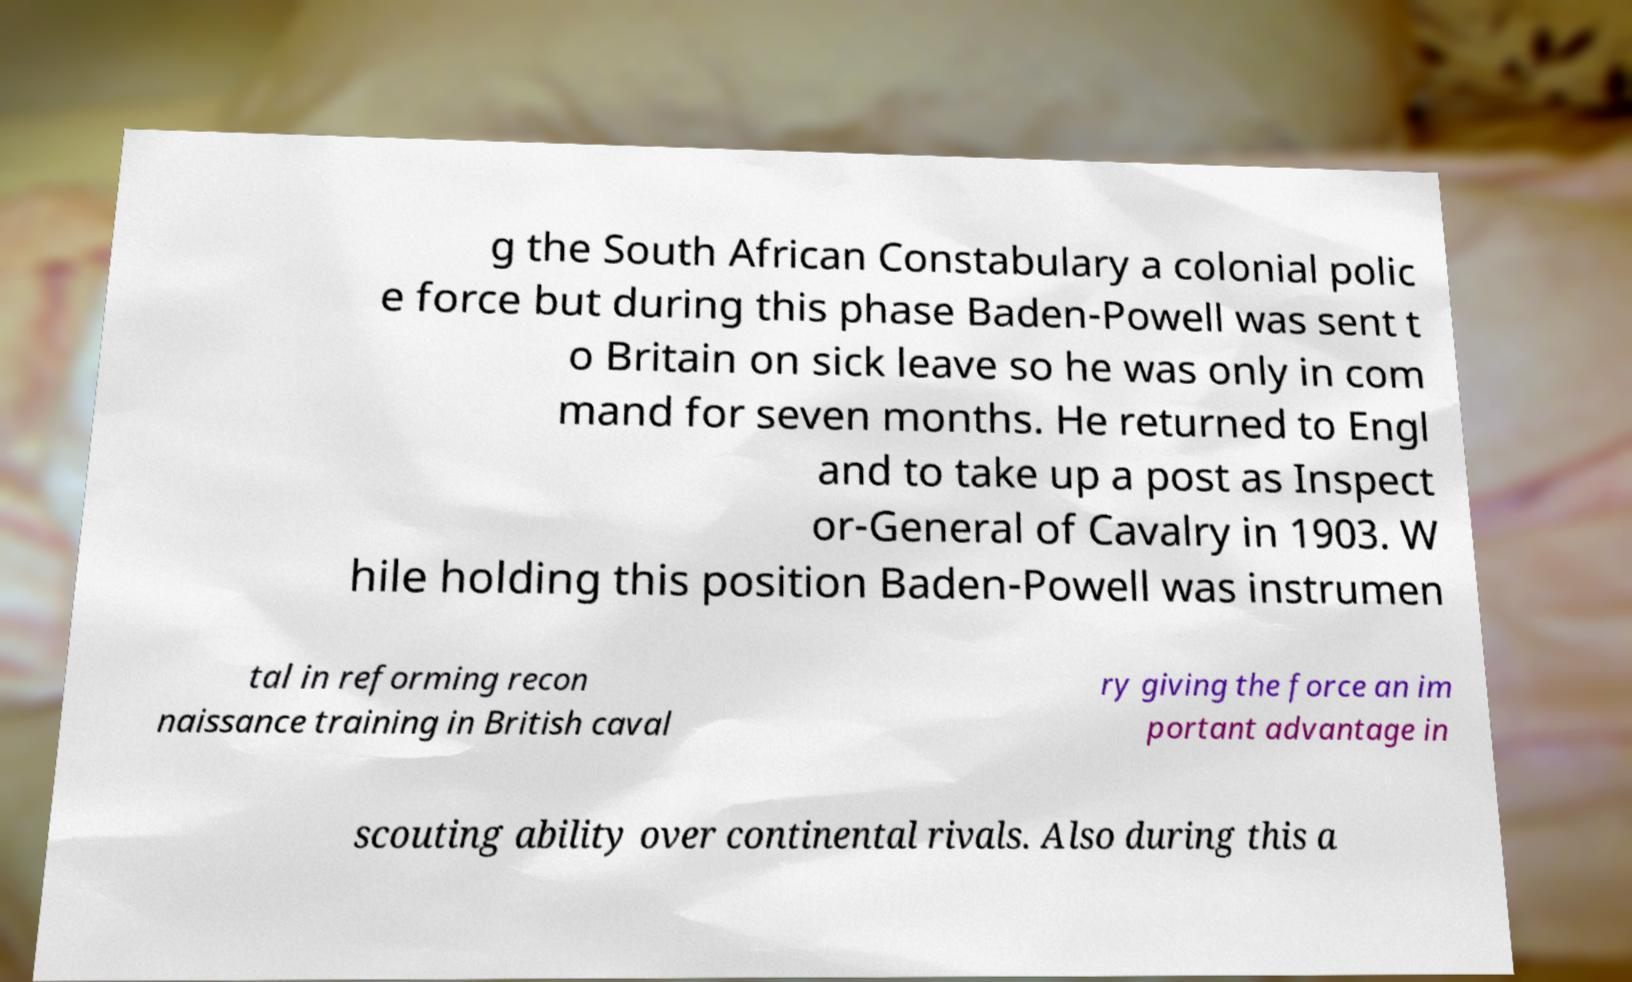Could you extract and type out the text from this image? g the South African Constabulary a colonial polic e force but during this phase Baden-Powell was sent t o Britain on sick leave so he was only in com mand for seven months. He returned to Engl and to take up a post as Inspect or-General of Cavalry in 1903. W hile holding this position Baden-Powell was instrumen tal in reforming recon naissance training in British caval ry giving the force an im portant advantage in scouting ability over continental rivals. Also during this a 